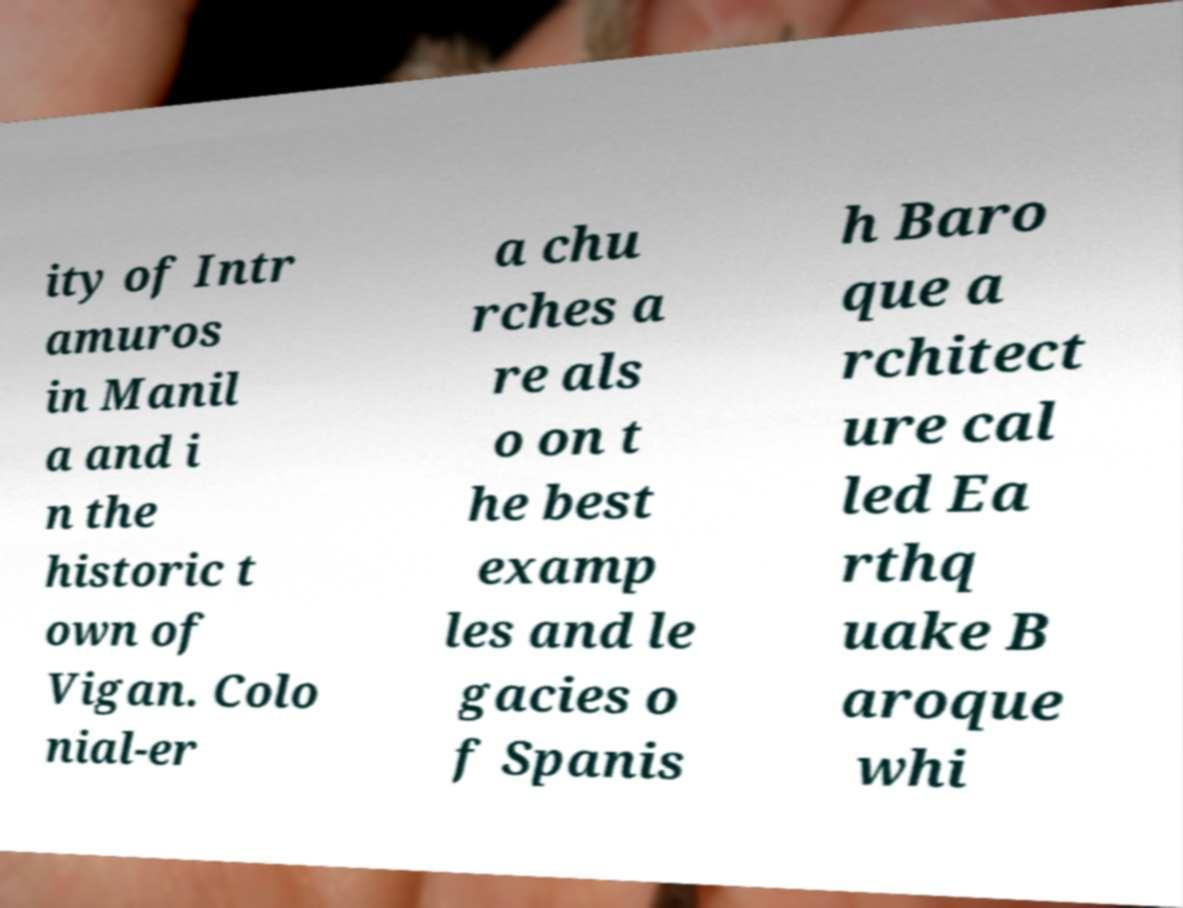Can you accurately transcribe the text from the provided image for me? ity of Intr amuros in Manil a and i n the historic t own of Vigan. Colo nial-er a chu rches a re als o on t he best examp les and le gacies o f Spanis h Baro que a rchitect ure cal led Ea rthq uake B aroque whi 